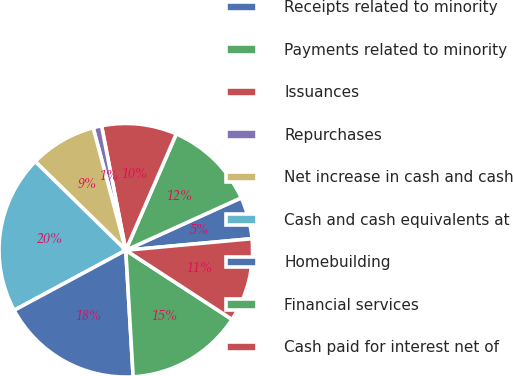Convert chart to OTSL. <chart><loc_0><loc_0><loc_500><loc_500><pie_chart><fcel>Receipts related to minority<fcel>Payments related to minority<fcel>Issuances<fcel>Repurchases<fcel>Net increase in cash and cash<fcel>Cash and cash equivalents at<fcel>Homebuilding<fcel>Financial services<fcel>Cash paid for interest net of<nl><fcel>5.33%<fcel>11.7%<fcel>9.58%<fcel>1.08%<fcel>8.52%<fcel>20.19%<fcel>18.07%<fcel>14.89%<fcel>10.64%<nl></chart> 